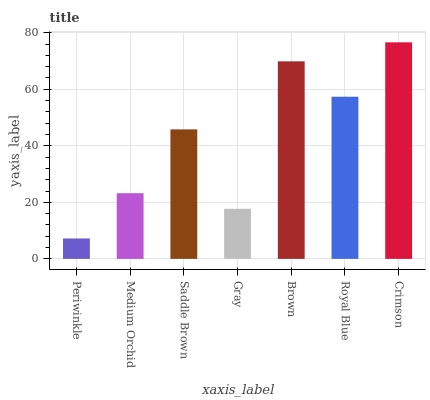Is Periwinkle the minimum?
Answer yes or no. Yes. Is Crimson the maximum?
Answer yes or no. Yes. Is Medium Orchid the minimum?
Answer yes or no. No. Is Medium Orchid the maximum?
Answer yes or no. No. Is Medium Orchid greater than Periwinkle?
Answer yes or no. Yes. Is Periwinkle less than Medium Orchid?
Answer yes or no. Yes. Is Periwinkle greater than Medium Orchid?
Answer yes or no. No. Is Medium Orchid less than Periwinkle?
Answer yes or no. No. Is Saddle Brown the high median?
Answer yes or no. Yes. Is Saddle Brown the low median?
Answer yes or no. Yes. Is Brown the high median?
Answer yes or no. No. Is Crimson the low median?
Answer yes or no. No. 